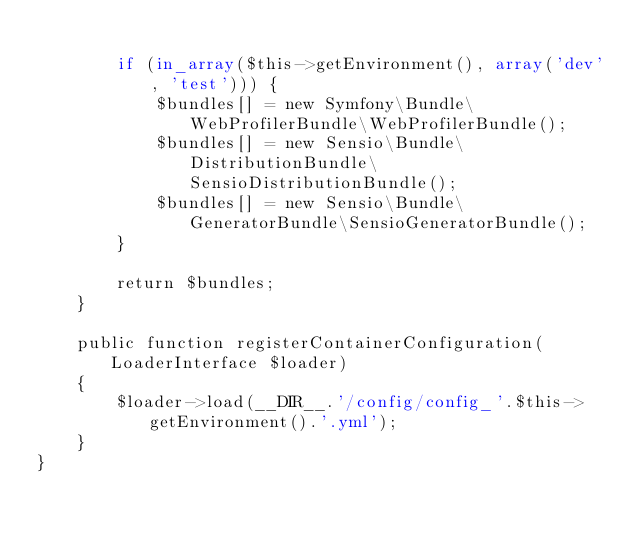<code> <loc_0><loc_0><loc_500><loc_500><_PHP_>
        if (in_array($this->getEnvironment(), array('dev', 'test'))) {
            $bundles[] = new Symfony\Bundle\WebProfilerBundle\WebProfilerBundle();
            $bundles[] = new Sensio\Bundle\DistributionBundle\SensioDistributionBundle();
            $bundles[] = new Sensio\Bundle\GeneratorBundle\SensioGeneratorBundle();
        }

        return $bundles;
    }

    public function registerContainerConfiguration(LoaderInterface $loader)
    {
        $loader->load(__DIR__.'/config/config_'.$this->getEnvironment().'.yml');
    }
}
</code> 